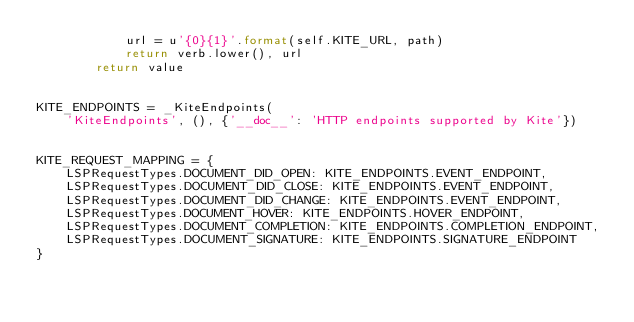Convert code to text. <code><loc_0><loc_0><loc_500><loc_500><_Python_>            url = u'{0}{1}'.format(self.KITE_URL, path)
            return verb.lower(), url
        return value


KITE_ENDPOINTS = _KiteEndpoints(
    'KiteEndpoints', (), {'__doc__': 'HTTP endpoints supported by Kite'})


KITE_REQUEST_MAPPING = {
    LSPRequestTypes.DOCUMENT_DID_OPEN: KITE_ENDPOINTS.EVENT_ENDPOINT,
    LSPRequestTypes.DOCUMENT_DID_CLOSE: KITE_ENDPOINTS.EVENT_ENDPOINT,
    LSPRequestTypes.DOCUMENT_DID_CHANGE: KITE_ENDPOINTS.EVENT_ENDPOINT,
    LSPRequestTypes.DOCUMENT_HOVER: KITE_ENDPOINTS.HOVER_ENDPOINT,
    LSPRequestTypes.DOCUMENT_COMPLETION: KITE_ENDPOINTS.COMPLETION_ENDPOINT,
    LSPRequestTypes.DOCUMENT_SIGNATURE: KITE_ENDPOINTS.SIGNATURE_ENDPOINT
}
</code> 